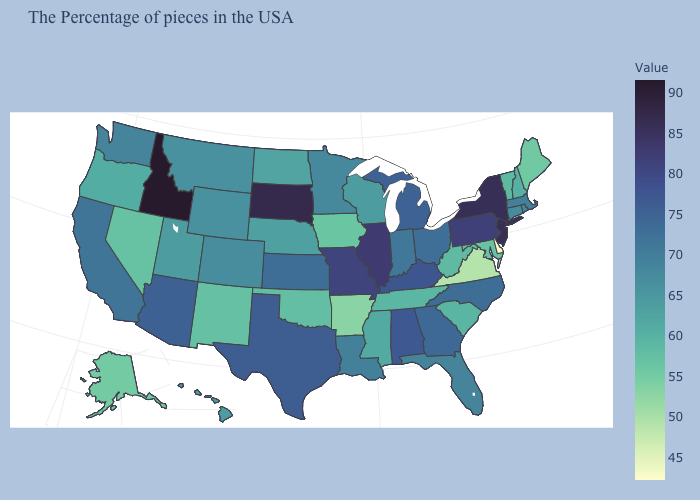Is the legend a continuous bar?
Answer briefly. Yes. Among the states that border Rhode Island , does Connecticut have the lowest value?
Quick response, please. Yes. Does Nevada have the highest value in the USA?
Concise answer only. No. Which states have the lowest value in the South?
Short answer required. Delaware. Does Idaho have the highest value in the West?
Answer briefly. Yes. Is the legend a continuous bar?
Quick response, please. Yes. 